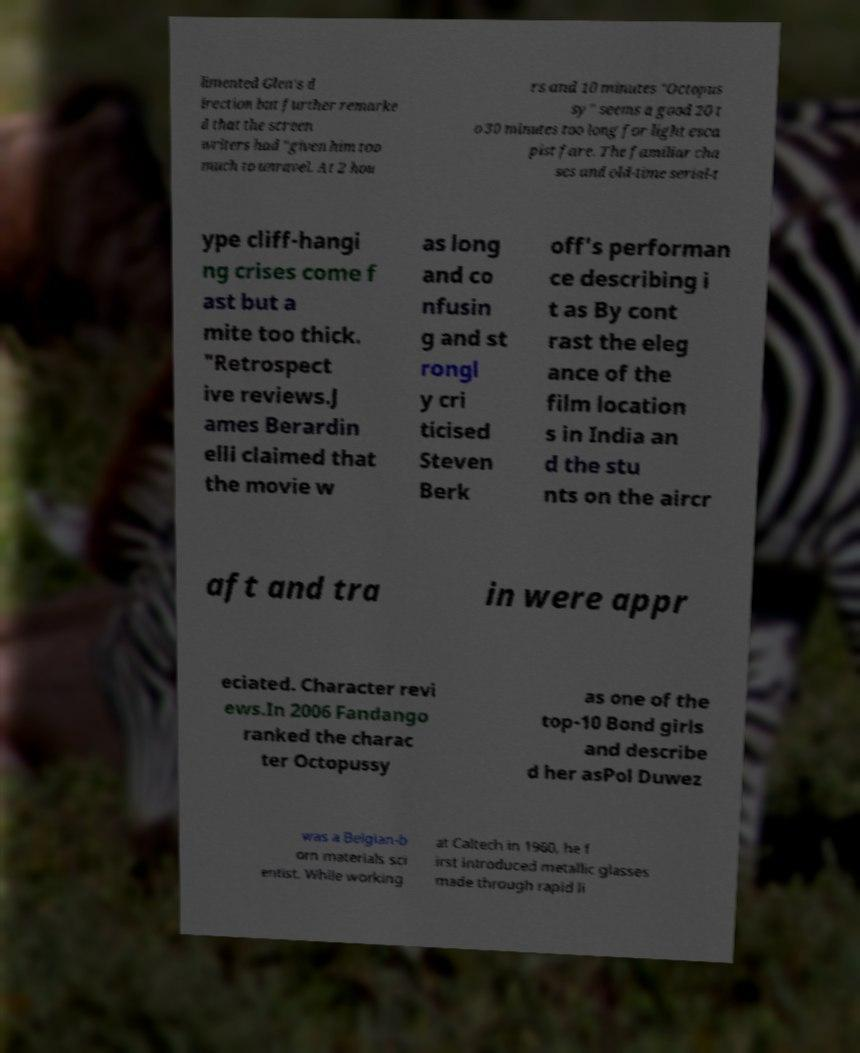Can you accurately transcribe the text from the provided image for me? limented Glen's d irection but further remarke d that the screen writers had "given him too much to unravel. At 2 hou rs and 10 minutes "Octopus sy" seems a good 20 t o 30 minutes too long for light esca pist fare. The familiar cha ses and old-time serial-t ype cliff-hangi ng crises come f ast but a mite too thick. "Retrospect ive reviews.J ames Berardin elli claimed that the movie w as long and co nfusin g and st rongl y cri ticised Steven Berk off's performan ce describing i t as By cont rast the eleg ance of the film location s in India an d the stu nts on the aircr aft and tra in were appr eciated. Character revi ews.In 2006 Fandango ranked the charac ter Octopussy as one of the top-10 Bond girls and describe d her asPol Duwez was a Belgian-b orn materials sci entist. While working at Caltech in 1960, he f irst introduced metallic glasses made through rapid li 